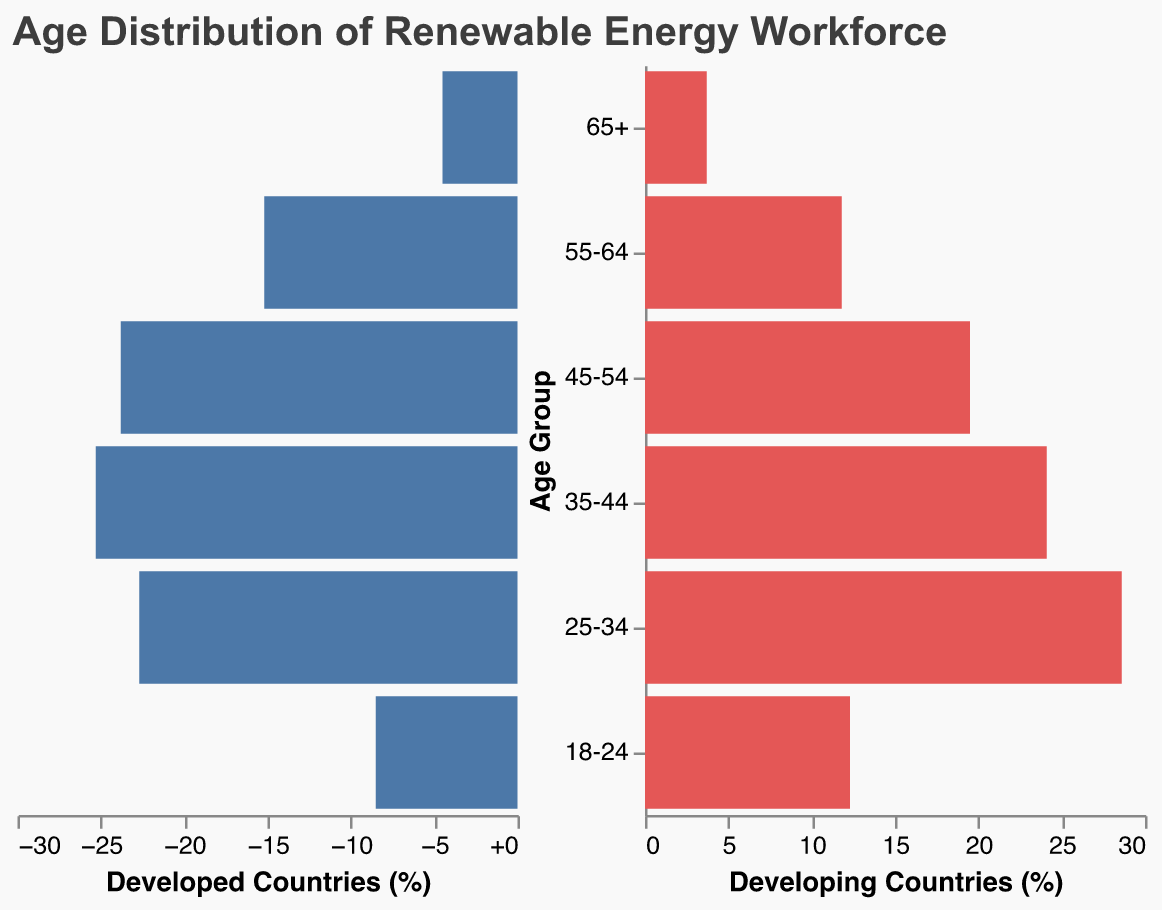What's the age group with the highest percentage in developed countries? By examining the "Developed Countries (%)" values, we see that the 35-44 age group has the highest value at 25.3%.
Answer: 35-44 What's the total percentage of workforce aged 55+ in developing countries? Sum the values of the age groups 55-64 and 65+ in the "Developing Countries (%)": 11.8% + 3.7% = 15.5%.
Answer: 15.5% Which age group has a higher percentage in developing countries compared to developed countries? Compare each age group between "Developed Countries (%)" and "Developing Countries (%)". The 18-24 and 25-34 age groups have higher percentages in developing countries.
Answer: 18-24, 25-34 What's the difference in the percentage of the 45-54 age group between developed and developing countries? Subtract the "Developing Countries (%)" value from the "Developed Countries (%)" for the 45-54 age group: 23.8% - 19.5% = 4.3%.
Answer: 4.3% Which age group has the closest percentage values between developed and developing countries? Compare the differences between each age group's percentages. The 35-44 age group has the closest values, with a difference of 25.3% - 24.1% = 1.2%.
Answer: 35-44 How do the workforce distributions in developed and developing countries compare for the youngest and oldest age groups? Compare the "18-24" and "65+" age groups in both segments. The 18-24 age group has higher percentages in developing countries (12.3% vs. 8.5%), and the 65+ age group also has higher percentages in developing countries (4.5% vs. 3.7%).
Answer: Developing countries have higher percentages in both 18-24 and 65+ age groups 